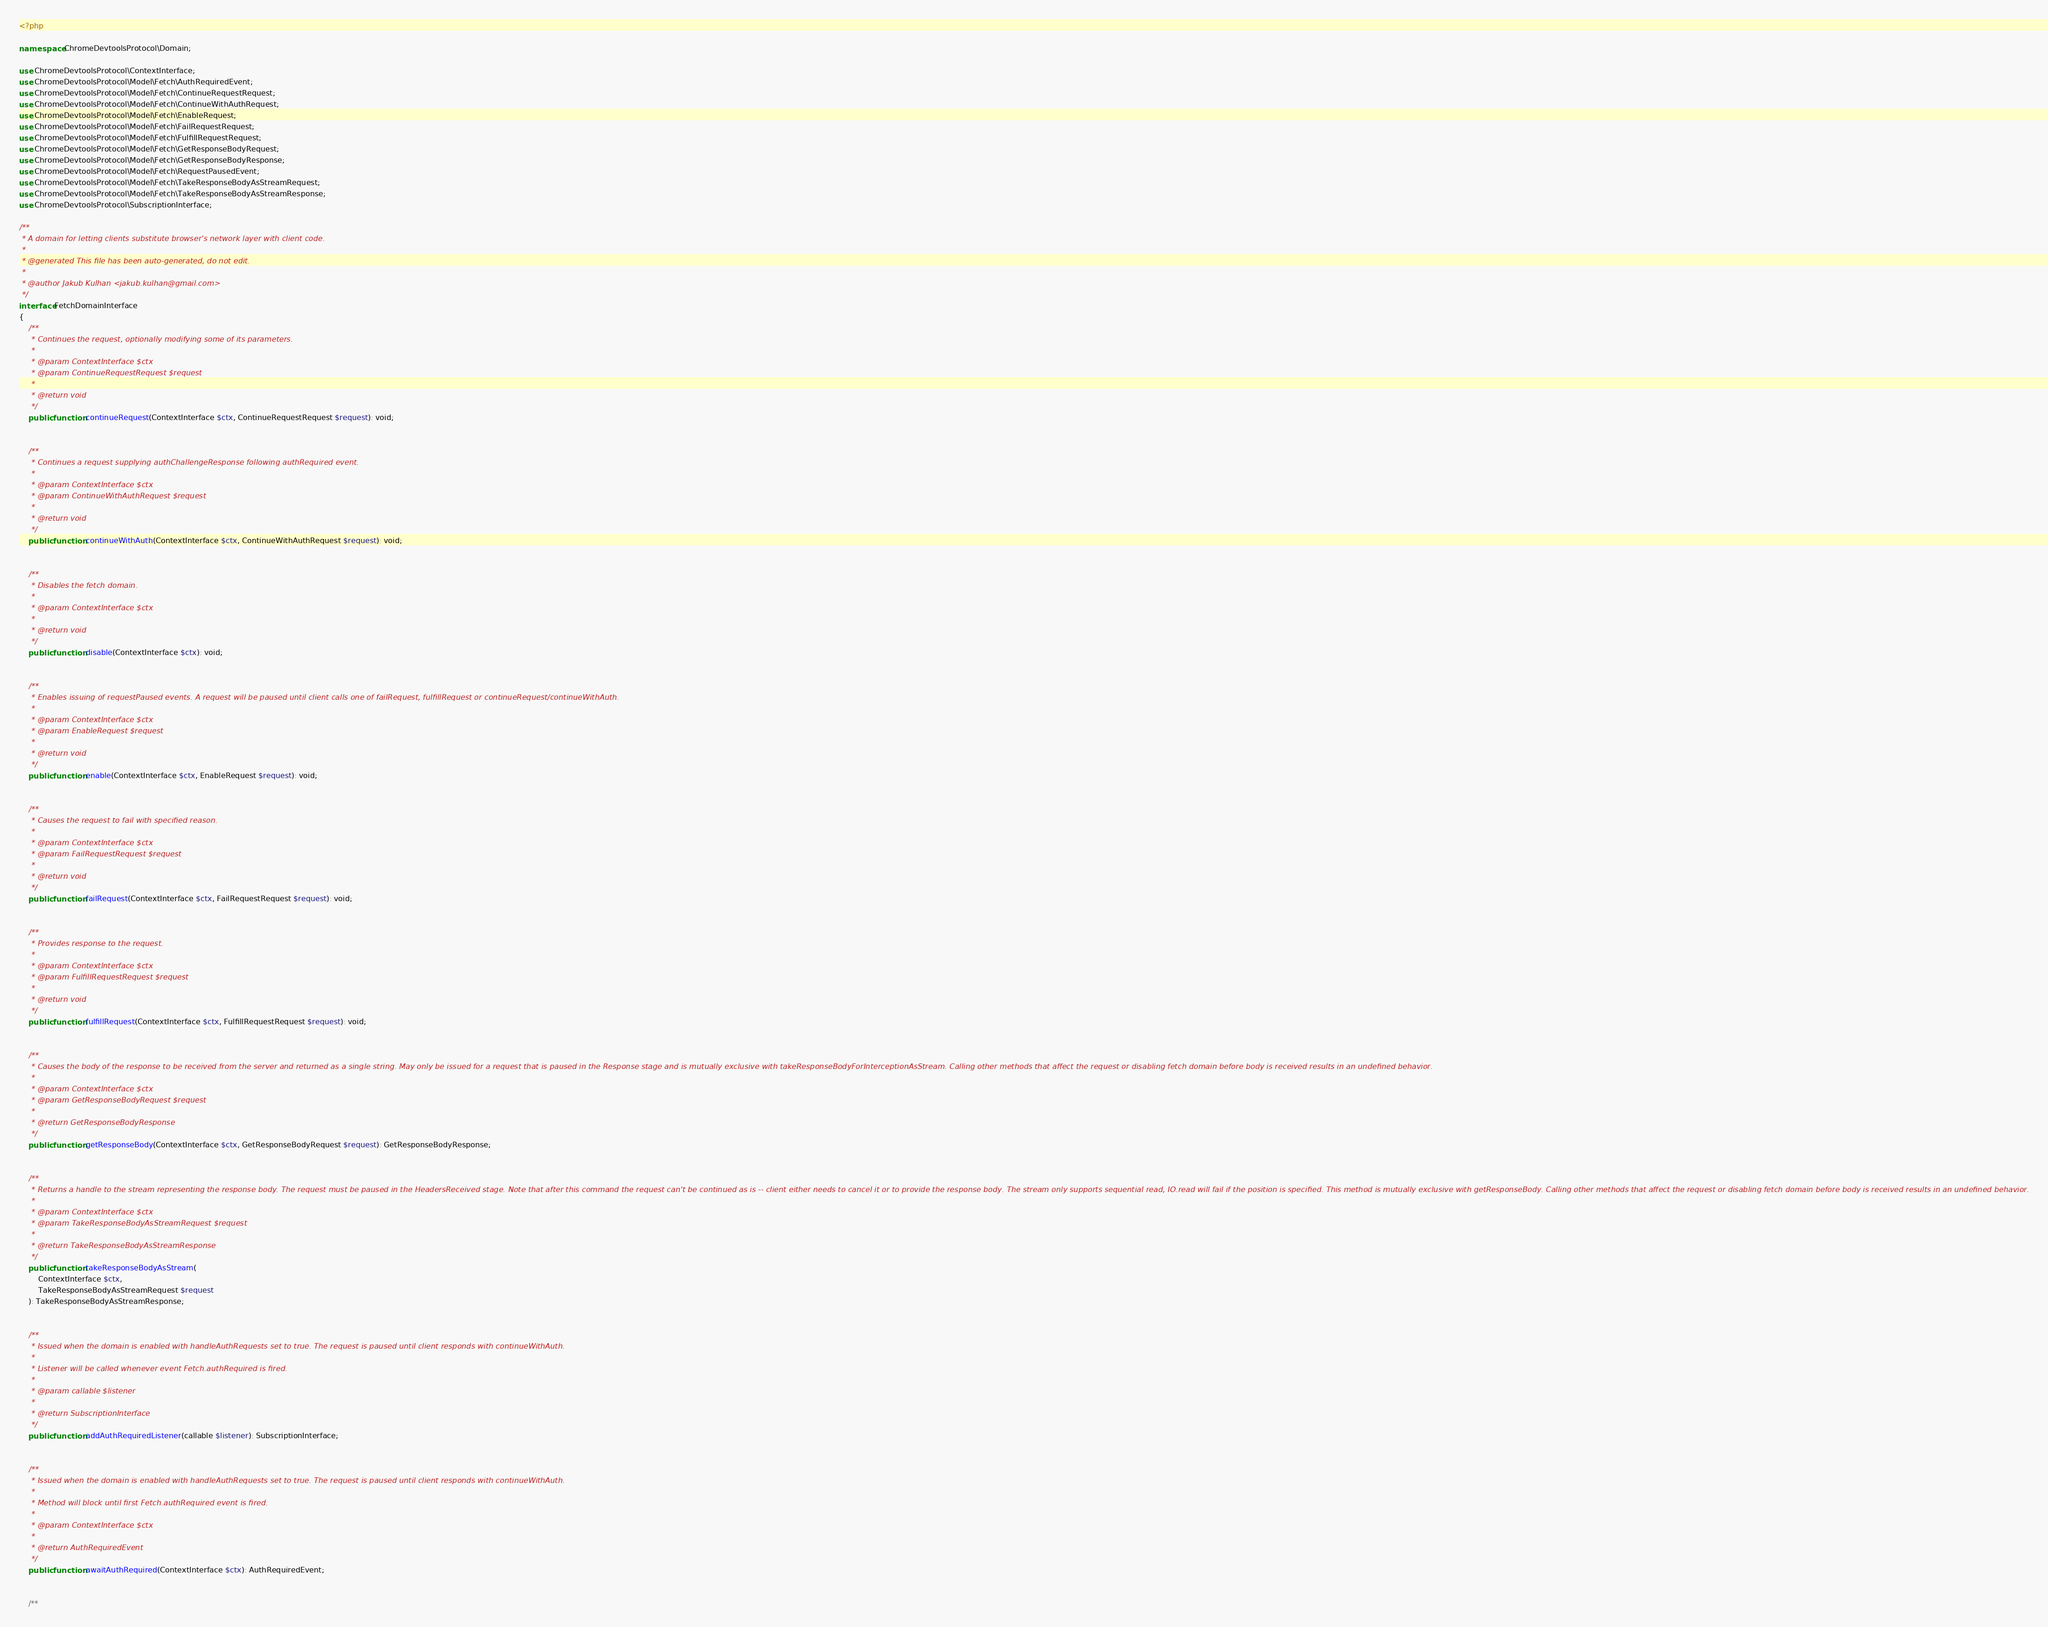Convert code to text. <code><loc_0><loc_0><loc_500><loc_500><_PHP_><?php

namespace ChromeDevtoolsProtocol\Domain;

use ChromeDevtoolsProtocol\ContextInterface;
use ChromeDevtoolsProtocol\Model\Fetch\AuthRequiredEvent;
use ChromeDevtoolsProtocol\Model\Fetch\ContinueRequestRequest;
use ChromeDevtoolsProtocol\Model\Fetch\ContinueWithAuthRequest;
use ChromeDevtoolsProtocol\Model\Fetch\EnableRequest;
use ChromeDevtoolsProtocol\Model\Fetch\FailRequestRequest;
use ChromeDevtoolsProtocol\Model\Fetch\FulfillRequestRequest;
use ChromeDevtoolsProtocol\Model\Fetch\GetResponseBodyRequest;
use ChromeDevtoolsProtocol\Model\Fetch\GetResponseBodyResponse;
use ChromeDevtoolsProtocol\Model\Fetch\RequestPausedEvent;
use ChromeDevtoolsProtocol\Model\Fetch\TakeResponseBodyAsStreamRequest;
use ChromeDevtoolsProtocol\Model\Fetch\TakeResponseBodyAsStreamResponse;
use ChromeDevtoolsProtocol\SubscriptionInterface;

/**
 * A domain for letting clients substitute browser's network layer with client code.
 *
 * @generated This file has been auto-generated, do not edit.
 *
 * @author Jakub Kulhan <jakub.kulhan@gmail.com>
 */
interface FetchDomainInterface
{
	/**
	 * Continues the request, optionally modifying some of its parameters.
	 *
	 * @param ContextInterface $ctx
	 * @param ContinueRequestRequest $request
	 *
	 * @return void
	 */
	public function continueRequest(ContextInterface $ctx, ContinueRequestRequest $request): void;


	/**
	 * Continues a request supplying authChallengeResponse following authRequired event.
	 *
	 * @param ContextInterface $ctx
	 * @param ContinueWithAuthRequest $request
	 *
	 * @return void
	 */
	public function continueWithAuth(ContextInterface $ctx, ContinueWithAuthRequest $request): void;


	/**
	 * Disables the fetch domain.
	 *
	 * @param ContextInterface $ctx
	 *
	 * @return void
	 */
	public function disable(ContextInterface $ctx): void;


	/**
	 * Enables issuing of requestPaused events. A request will be paused until client calls one of failRequest, fulfillRequest or continueRequest/continueWithAuth.
	 *
	 * @param ContextInterface $ctx
	 * @param EnableRequest $request
	 *
	 * @return void
	 */
	public function enable(ContextInterface $ctx, EnableRequest $request): void;


	/**
	 * Causes the request to fail with specified reason.
	 *
	 * @param ContextInterface $ctx
	 * @param FailRequestRequest $request
	 *
	 * @return void
	 */
	public function failRequest(ContextInterface $ctx, FailRequestRequest $request): void;


	/**
	 * Provides response to the request.
	 *
	 * @param ContextInterface $ctx
	 * @param FulfillRequestRequest $request
	 *
	 * @return void
	 */
	public function fulfillRequest(ContextInterface $ctx, FulfillRequestRequest $request): void;


	/**
	 * Causes the body of the response to be received from the server and returned as a single string. May only be issued for a request that is paused in the Response stage and is mutually exclusive with takeResponseBodyForInterceptionAsStream. Calling other methods that affect the request or disabling fetch domain before body is received results in an undefined behavior.
	 *
	 * @param ContextInterface $ctx
	 * @param GetResponseBodyRequest $request
	 *
	 * @return GetResponseBodyResponse
	 */
	public function getResponseBody(ContextInterface $ctx, GetResponseBodyRequest $request): GetResponseBodyResponse;


	/**
	 * Returns a handle to the stream representing the response body. The request must be paused in the HeadersReceived stage. Note that after this command the request can't be continued as is -- client either needs to cancel it or to provide the response body. The stream only supports sequential read, IO.read will fail if the position is specified. This method is mutually exclusive with getResponseBody. Calling other methods that affect the request or disabling fetch domain before body is received results in an undefined behavior.
	 *
	 * @param ContextInterface $ctx
	 * @param TakeResponseBodyAsStreamRequest $request
	 *
	 * @return TakeResponseBodyAsStreamResponse
	 */
	public function takeResponseBodyAsStream(
		ContextInterface $ctx,
		TakeResponseBodyAsStreamRequest $request
	): TakeResponseBodyAsStreamResponse;


	/**
	 * Issued when the domain is enabled with handleAuthRequests set to true. The request is paused until client responds with continueWithAuth.
	 *
	 * Listener will be called whenever event Fetch.authRequired is fired.
	 *
	 * @param callable $listener
	 *
	 * @return SubscriptionInterface
	 */
	public function addAuthRequiredListener(callable $listener): SubscriptionInterface;


	/**
	 * Issued when the domain is enabled with handleAuthRequests set to true. The request is paused until client responds with continueWithAuth.
	 *
	 * Method will block until first Fetch.authRequired event is fired.
	 *
	 * @param ContextInterface $ctx
	 *
	 * @return AuthRequiredEvent
	 */
	public function awaitAuthRequired(ContextInterface $ctx): AuthRequiredEvent;


	/**</code> 